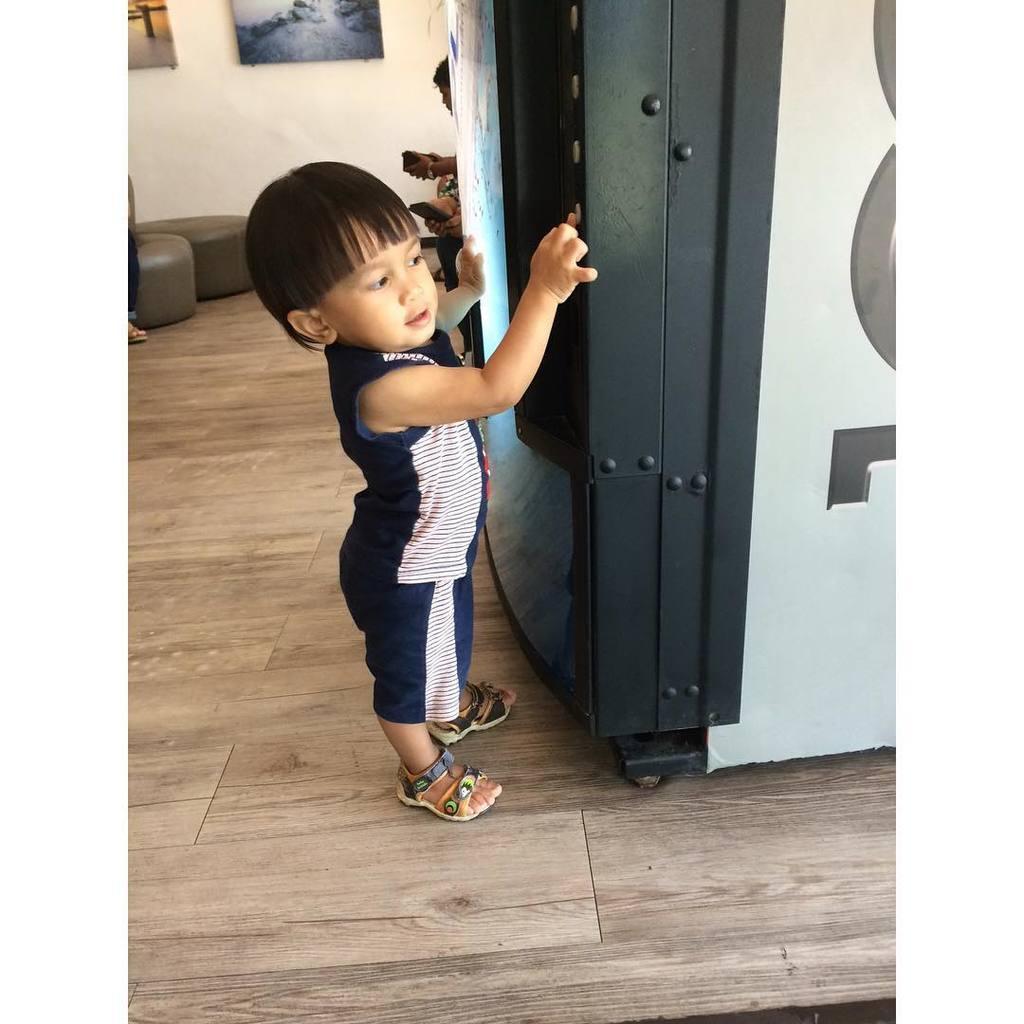How would you summarize this image in a sentence or two? As we can see in the image there is a refrigerator, a boy standing over here, sofa, wall and photo frames. 